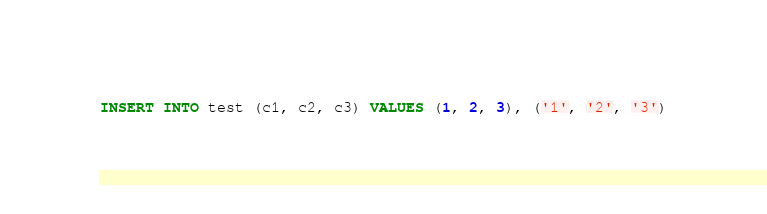<code> <loc_0><loc_0><loc_500><loc_500><_SQL_>INSERT INTO test (c1, c2, c3) VALUES (1, 2, 3), ('1', '2', '3')</code> 